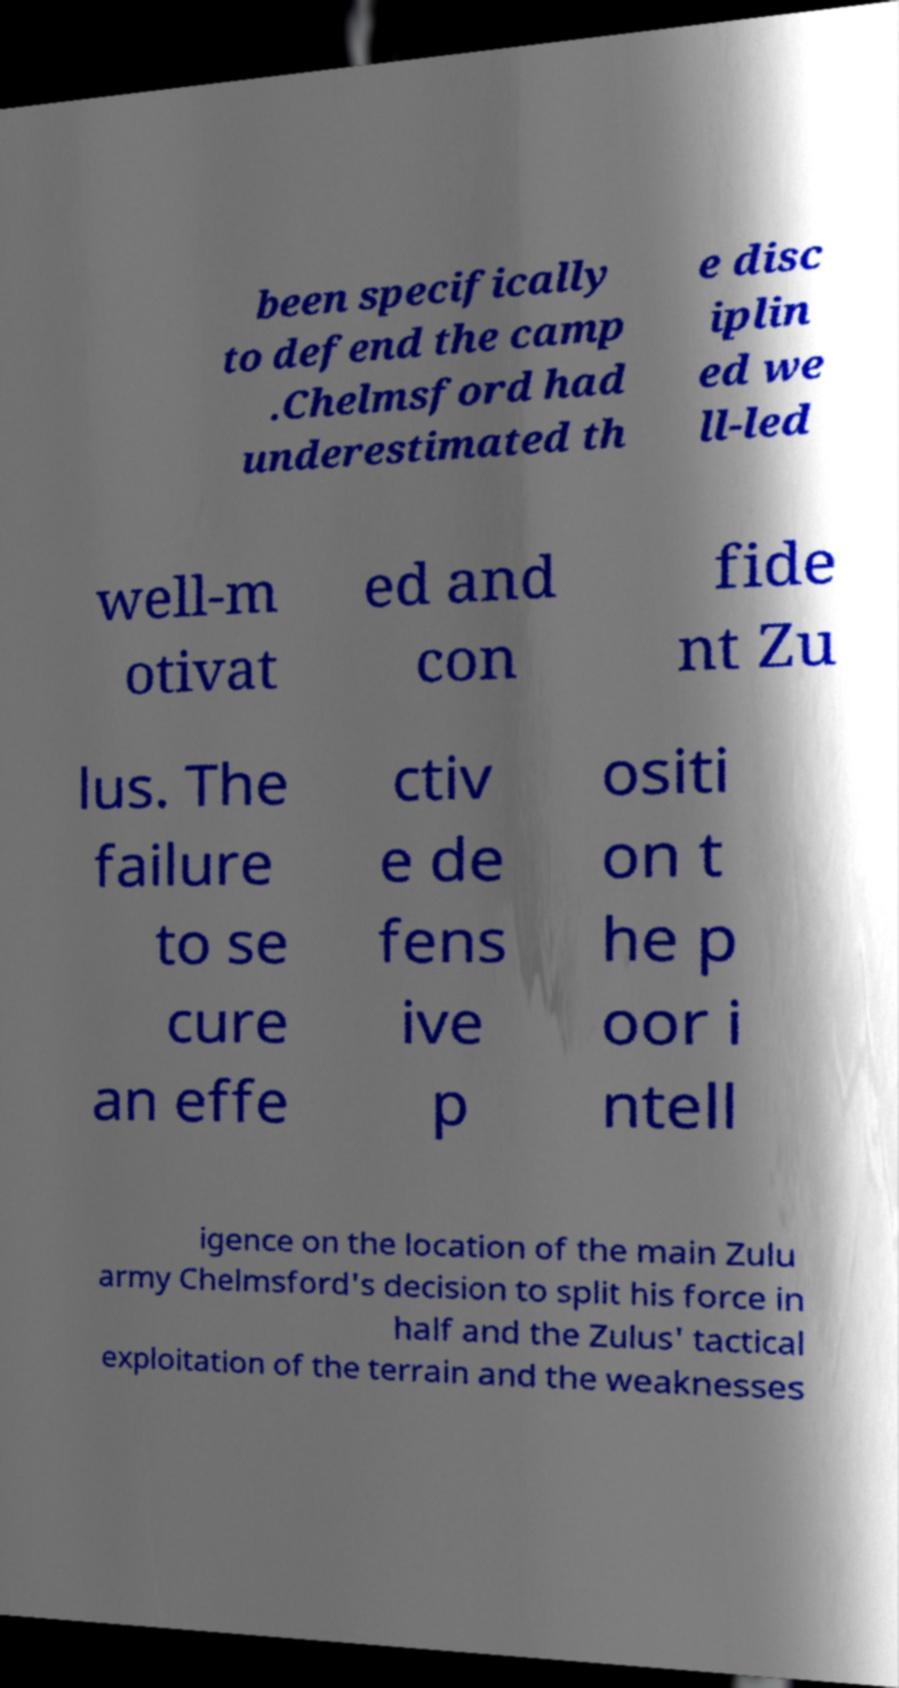Could you assist in decoding the text presented in this image and type it out clearly? been specifically to defend the camp .Chelmsford had underestimated th e disc iplin ed we ll-led well-m otivat ed and con fide nt Zu lus. The failure to se cure an effe ctiv e de fens ive p ositi on t he p oor i ntell igence on the location of the main Zulu army Chelmsford's decision to split his force in half and the Zulus' tactical exploitation of the terrain and the weaknesses 